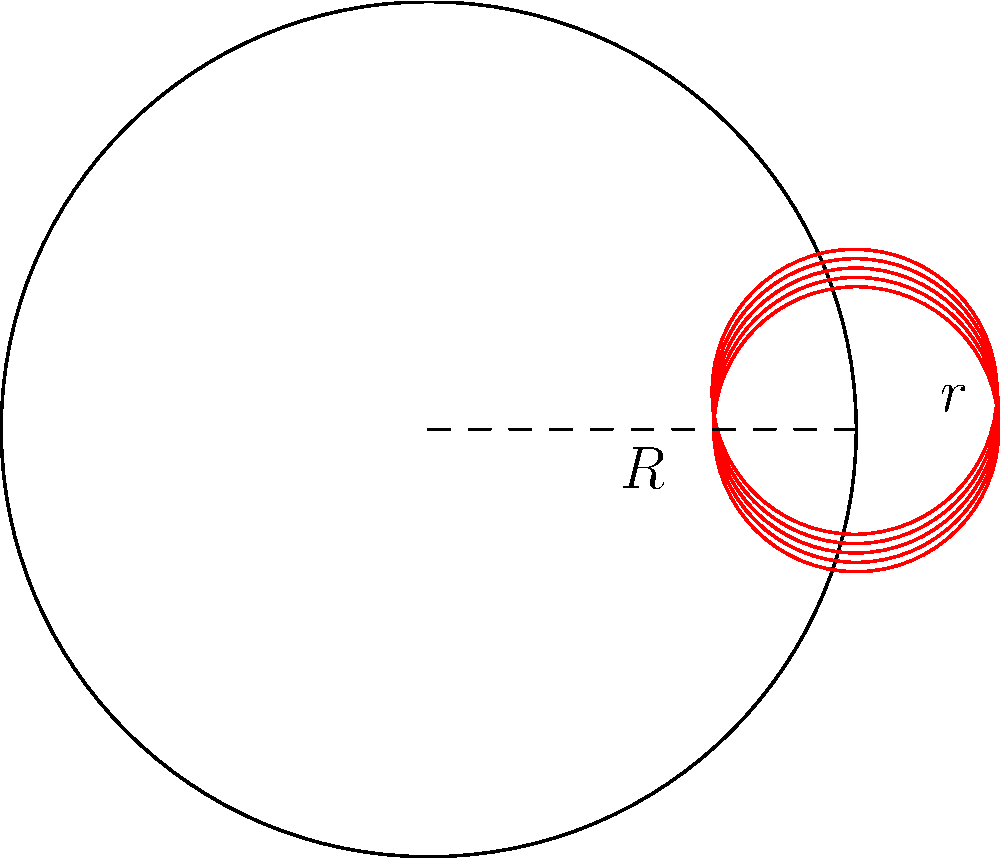A circular buffet table has a radius of 3 meters. You need to arrange chocolate trays, each with a radius of 1 meter, around the edge of the table. What is the maximum number of trays that can fit without overlapping, and what is the angle (in radians) between the centers of adjacent trays? To solve this problem, we need to follow these steps:

1) Let $R$ be the radius of the table (3 meters) and $r$ be the radius of each tray (1 meter).

2) The centers of the trays will form a regular polygon inscribed in a circle with radius $R-r = 2$ meters.

3) The maximum number of trays (n) that can fit is determined by the largest regular n-gon that can be inscribed in this circle.

4) For a regular n-gon, the angle between adjacent vertices (from the center) is $\frac{2\pi}{n}$.

5) The chord length between adjacent vertices is $2(R-r)\sin(\frac{\pi}{n})$.

6) For the trays to just touch, this chord length should be equal to $2r$.

7) So, we need to solve the equation: $2(R-r)\sin(\frac{\pi}{n}) = 2r$

8) Simplifying: $2\sin(\frac{\pi}{n}) = \frac{r}{R-r} = \frac{1}{2}$

9) Solving for n: $n = \frac{\pi}{\arcsin(\frac{1}{4})} \approx 5.74$

10) Since n must be an integer, we round down to 5.

11) The angle between the centers of adjacent trays is $\frac{2\pi}{5}$ radians.
Answer: 5 trays, $\frac{2\pi}{5}$ radians 